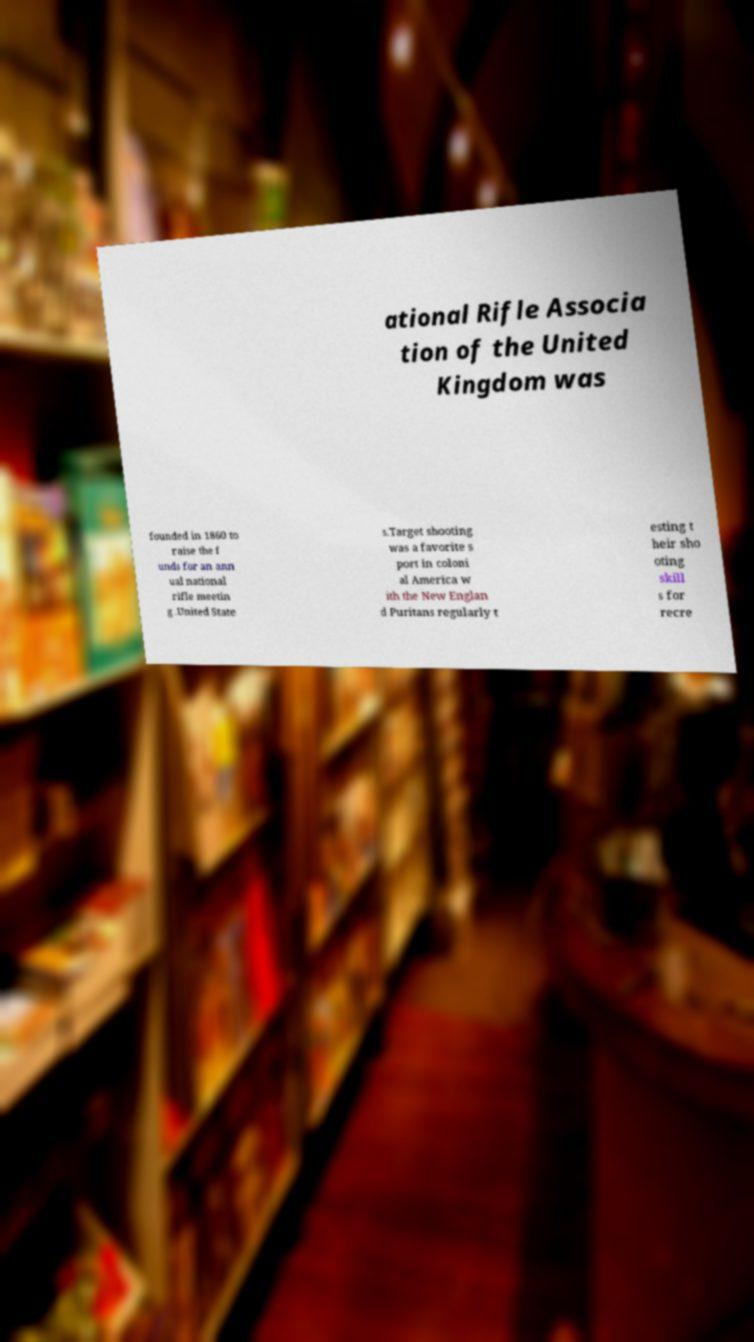Could you assist in decoding the text presented in this image and type it out clearly? ational Rifle Associa tion of the United Kingdom was founded in 1860 to raise the f unds for an ann ual national rifle meetin g .United State s.Target shooting was a favorite s port in coloni al America w ith the New Englan d Puritans regularly t esting t heir sho oting skill s for recre 